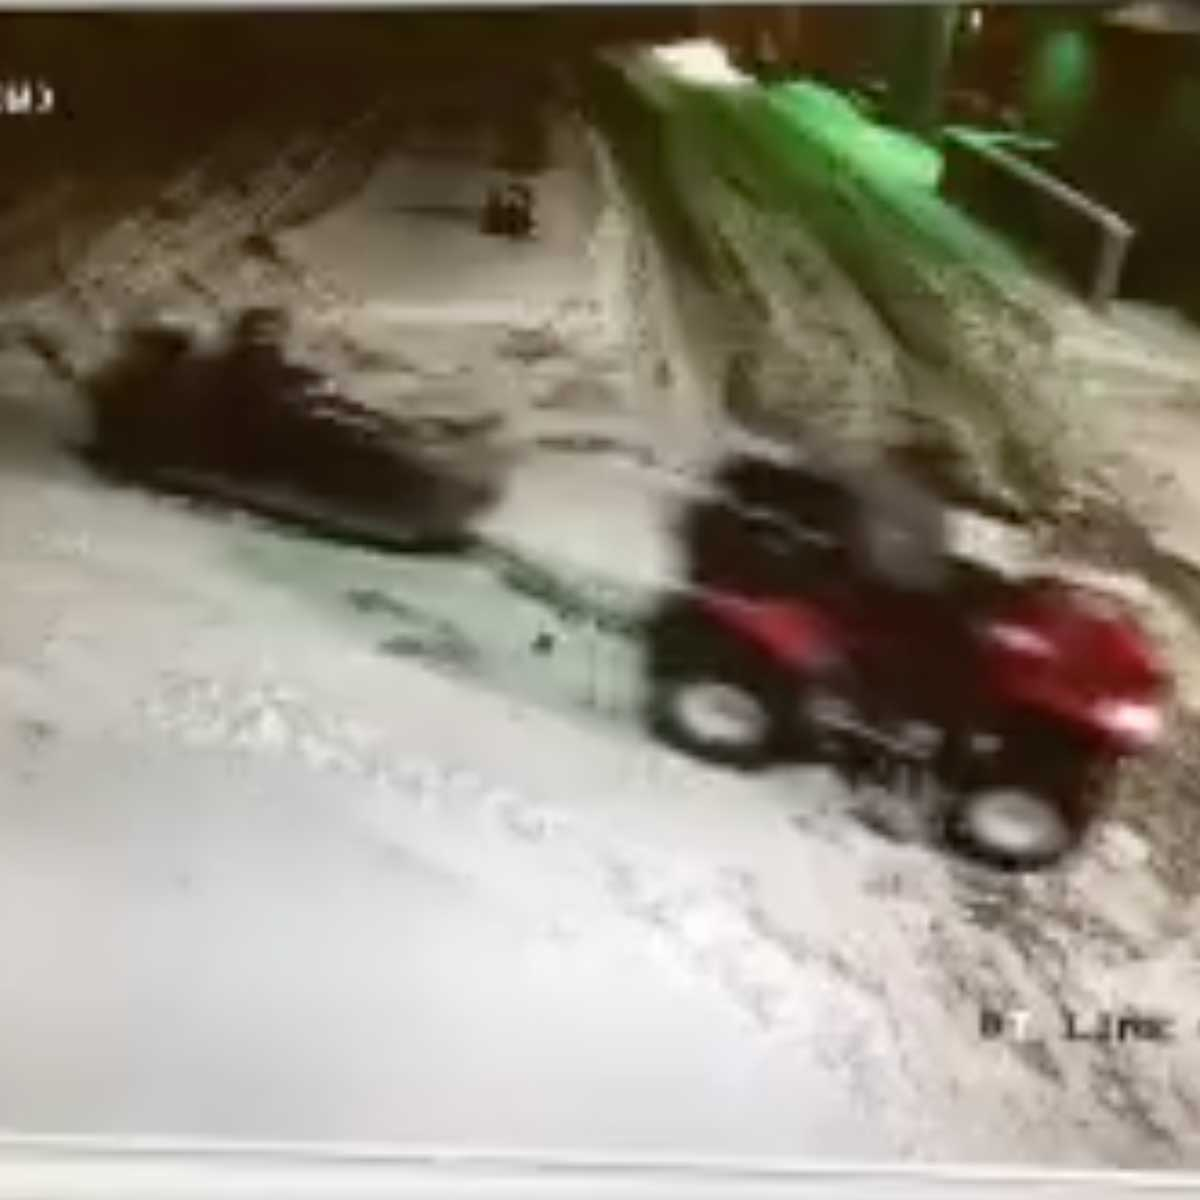What realistic scenario might explain this image? A realistic scenario could be that these vehicles are part of a team conducting maintenance work on a remote research station. The red ATV is driven by an engineer returning to base after inspecting equipment or sensors placed at a distance. The smaller object might be another ATV or equipment that has been left temporarily unattended while its operator checks on something nearby. The snow-covered terrain suggests challenging driving conditions, adding a layer of difficulty to their routine tasks in ensuring the smooth operation of the outpost. 
What could be a detailed story behind this image? In the middle of the Arctic, a small research team is stationed to gather crucial climate data. The team consists of scientists and engineers who carefully monitor remote equipment installed across a vast snowy landscape. One evening, after a day filled with data collection and equipment maintenance, tragedy strikes—a critical sensor issues a fault alert, threatening to compromise the entire month's data collection.

Without wasting any time, Sarah, the lead engineer, hops on her red ATV. She knows every minute counts as the impending snowstorm could bury the sensors or even damage them beyond repair. The smaller, darker object in the distance is another ATV driven by Mark, her colleague, who had set out earlier but experienced mechanical issues with his vehicle.

Sarah maneuvers through the icy paths, her headlamp cutting through the growing darkness. The unspoken tension of trying to outpace the incoming storm keeps her focused, as she navigates the slippery terrain with precision. Halfway through her journey, she spots Mark's immobilized ATV. Mark signals with his flashlight, and Sarah immediately heads in his direction. She helps Mark troubleshoot the problem, and together they manage to restart his engine. With synchronized effort, they make their way to the malfunctioning sensor, fix the issue, and secure the data just as the first heavy snowfall of the storm begins.

The image captures the critical moment just before Sarah and Mark link up to tackle the daunting challenges ahead. Their resilience and teamwork ensure the success of their mission, highlighting the dedication and courage required to conduct research in one of the most unforgiving environments on Earth. 